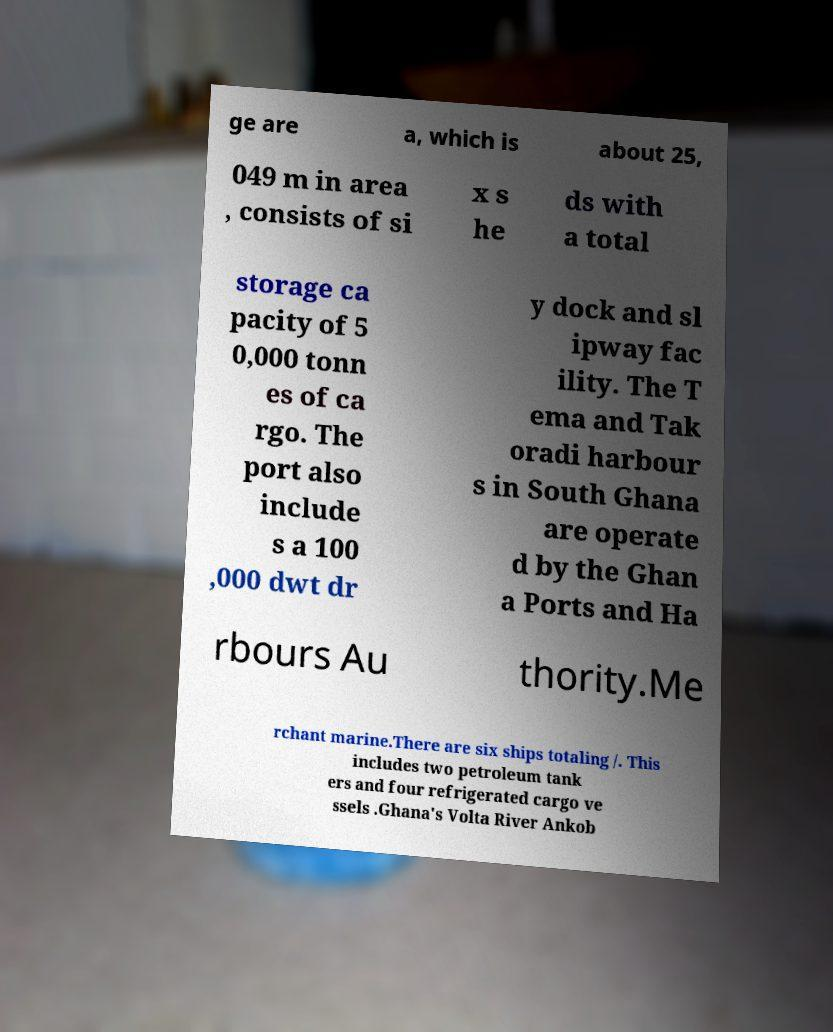Could you extract and type out the text from this image? ge are a, which is about 25, 049 m in area , consists of si x s he ds with a total storage ca pacity of 5 0,000 tonn es of ca rgo. The port also include s a 100 ,000 dwt dr y dock and sl ipway fac ility. The T ema and Tak oradi harbour s in South Ghana are operate d by the Ghan a Ports and Ha rbours Au thority.Me rchant marine.There are six ships totaling /. This includes two petroleum tank ers and four refrigerated cargo ve ssels .Ghana's Volta River Ankob 